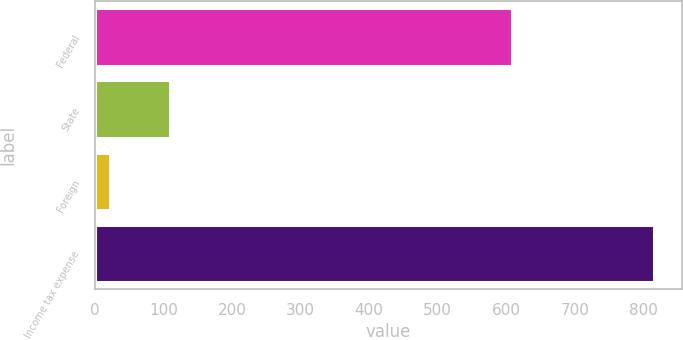<chart> <loc_0><loc_0><loc_500><loc_500><bar_chart><fcel>Federal<fcel>State<fcel>Foreign<fcel>Income tax expense<nl><fcel>609<fcel>110<fcel>22<fcel>815<nl></chart> 